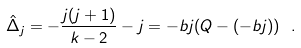<formula> <loc_0><loc_0><loc_500><loc_500>\hat { \Delta } _ { j } = - \frac { j ( j + 1 ) } { k - 2 } - j = - b j ( Q - ( - b j ) ) \ .</formula> 